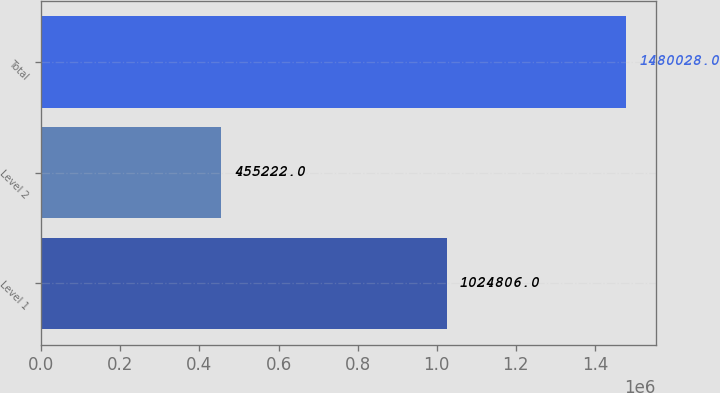<chart> <loc_0><loc_0><loc_500><loc_500><bar_chart><fcel>Level 1<fcel>Level 2<fcel>Total<nl><fcel>1.02481e+06<fcel>455222<fcel>1.48003e+06<nl></chart> 